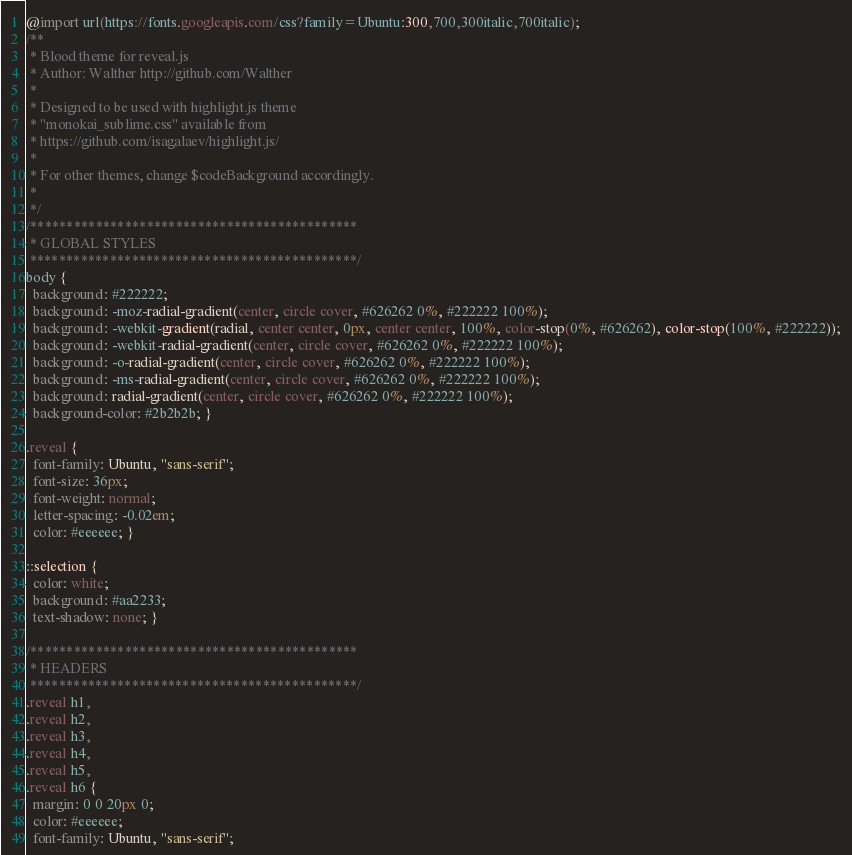Convert code to text. <code><loc_0><loc_0><loc_500><loc_500><_CSS_>@import url(https://fonts.googleapis.com/css?family=Ubuntu:300,700,300italic,700italic);
/**
 * Blood theme for reveal.js
 * Author: Walther http://github.com/Walther
 *
 * Designed to be used with highlight.js theme
 * "monokai_sublime.css" available from
 * https://github.com/isagalaev/highlight.js/
 *
 * For other themes, change $codeBackground accordingly.
 *
 */
/*********************************************
 * GLOBAL STYLES
 *********************************************/
body {
  background: #222222;
  background: -moz-radial-gradient(center, circle cover, #626262 0%, #222222 100%);
  background: -webkit-gradient(radial, center center, 0px, center center, 100%, color-stop(0%, #626262), color-stop(100%, #222222));
  background: -webkit-radial-gradient(center, circle cover, #626262 0%, #222222 100%);
  background: -o-radial-gradient(center, circle cover, #626262 0%, #222222 100%);
  background: -ms-radial-gradient(center, circle cover, #626262 0%, #222222 100%);
  background: radial-gradient(center, circle cover, #626262 0%, #222222 100%);
  background-color: #2b2b2b; }

.reveal {
  font-family: Ubuntu, "sans-serif";
  font-size: 36px;
  font-weight: normal;
  letter-spacing: -0.02em;
  color: #eeeeee; }

::selection {
  color: white;
  background: #aa2233;
  text-shadow: none; }

/*********************************************
 * HEADERS
 *********************************************/
.reveal h1,
.reveal h2,
.reveal h3,
.reveal h4,
.reveal h5,
.reveal h6 {
  margin: 0 0 20px 0;
  color: #eeeeee;
  font-family: Ubuntu, "sans-serif";</code> 